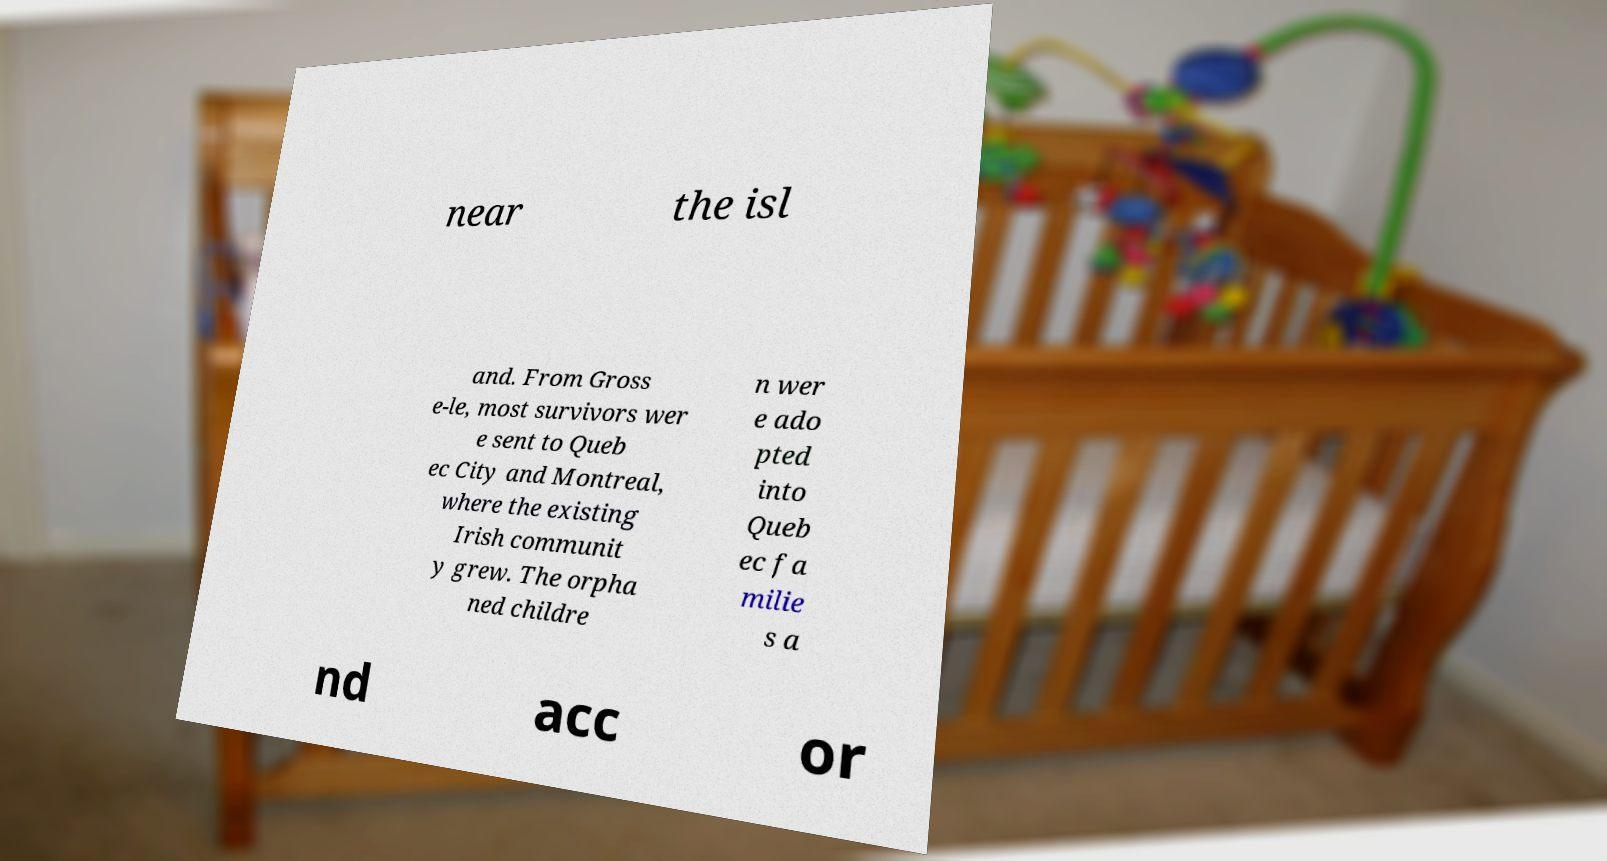Can you read and provide the text displayed in the image?This photo seems to have some interesting text. Can you extract and type it out for me? near the isl and. From Gross e-le, most survivors wer e sent to Queb ec City and Montreal, where the existing Irish communit y grew. The orpha ned childre n wer e ado pted into Queb ec fa milie s a nd acc or 